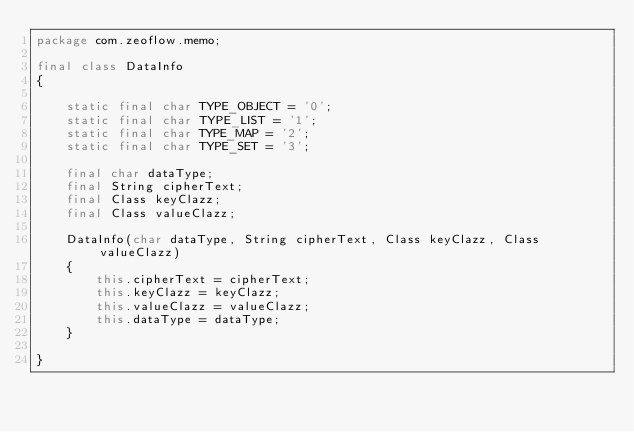Convert code to text. <code><loc_0><loc_0><loc_500><loc_500><_Java_>package com.zeoflow.memo;

final class DataInfo
{

    static final char TYPE_OBJECT = '0';
    static final char TYPE_LIST = '1';
    static final char TYPE_MAP = '2';
    static final char TYPE_SET = '3';

    final char dataType;
    final String cipherText;
    final Class keyClazz;
    final Class valueClazz;

    DataInfo(char dataType, String cipherText, Class keyClazz, Class valueClazz)
    {
        this.cipherText = cipherText;
        this.keyClazz = keyClazz;
        this.valueClazz = valueClazz;
        this.dataType = dataType;
    }

}
</code> 